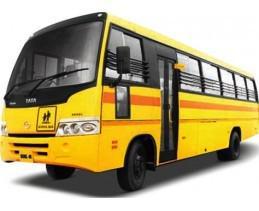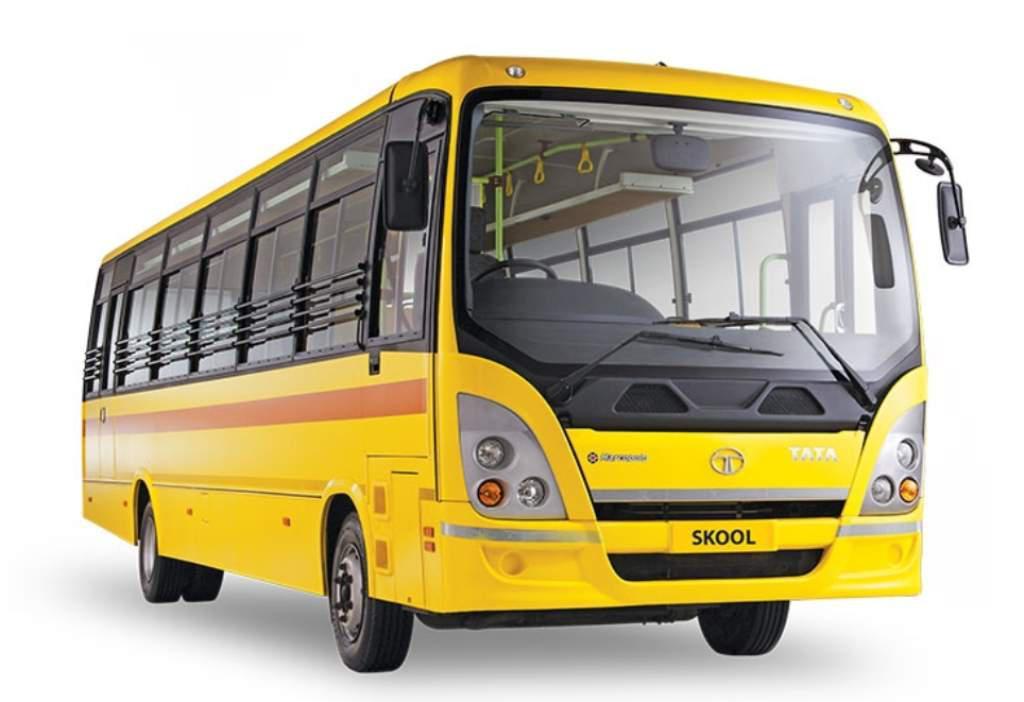The first image is the image on the left, the second image is the image on the right. For the images shown, is this caption "The vehicles are facing in the same direction." true? Answer yes or no. No. The first image is the image on the left, the second image is the image on the right. Analyze the images presented: Is the assertion "Both yellow buses are facing the same direction." valid? Answer yes or no. No. 